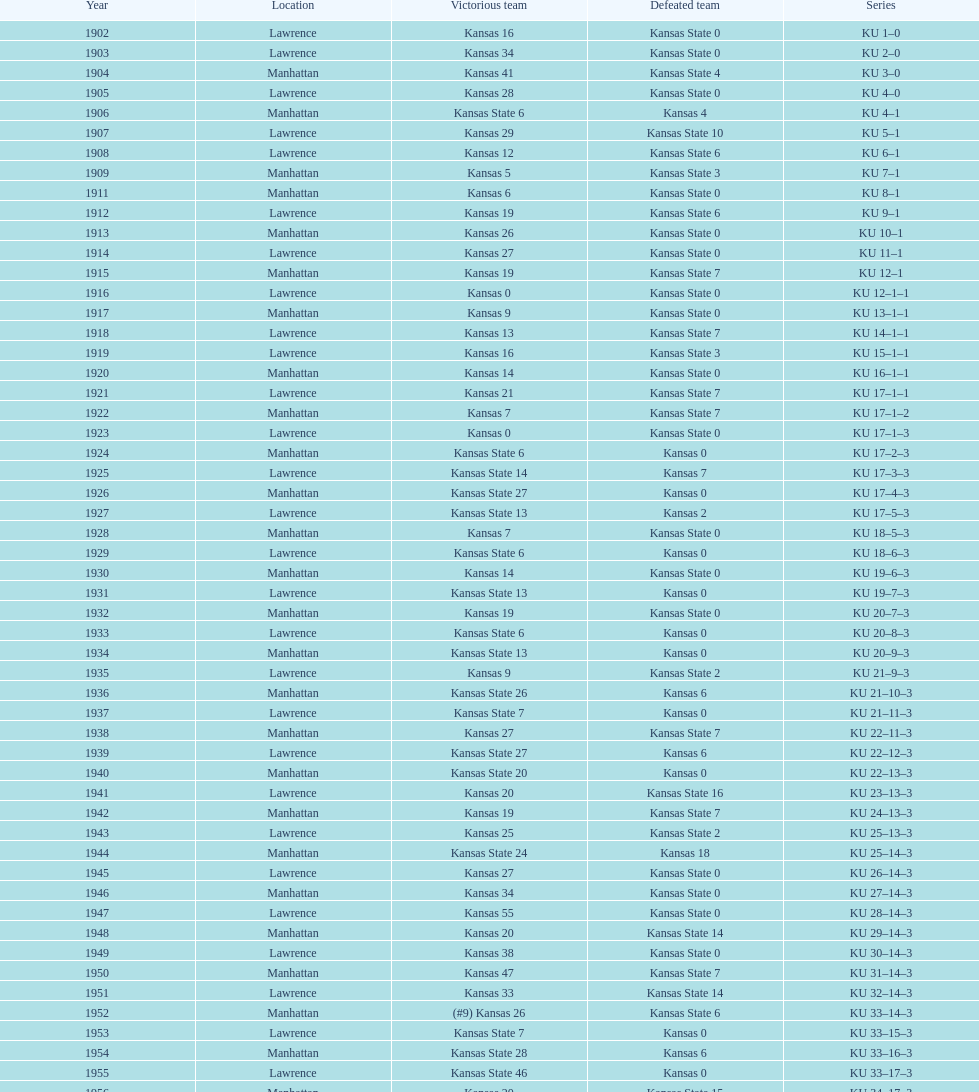What is the total number of games played? 66. 